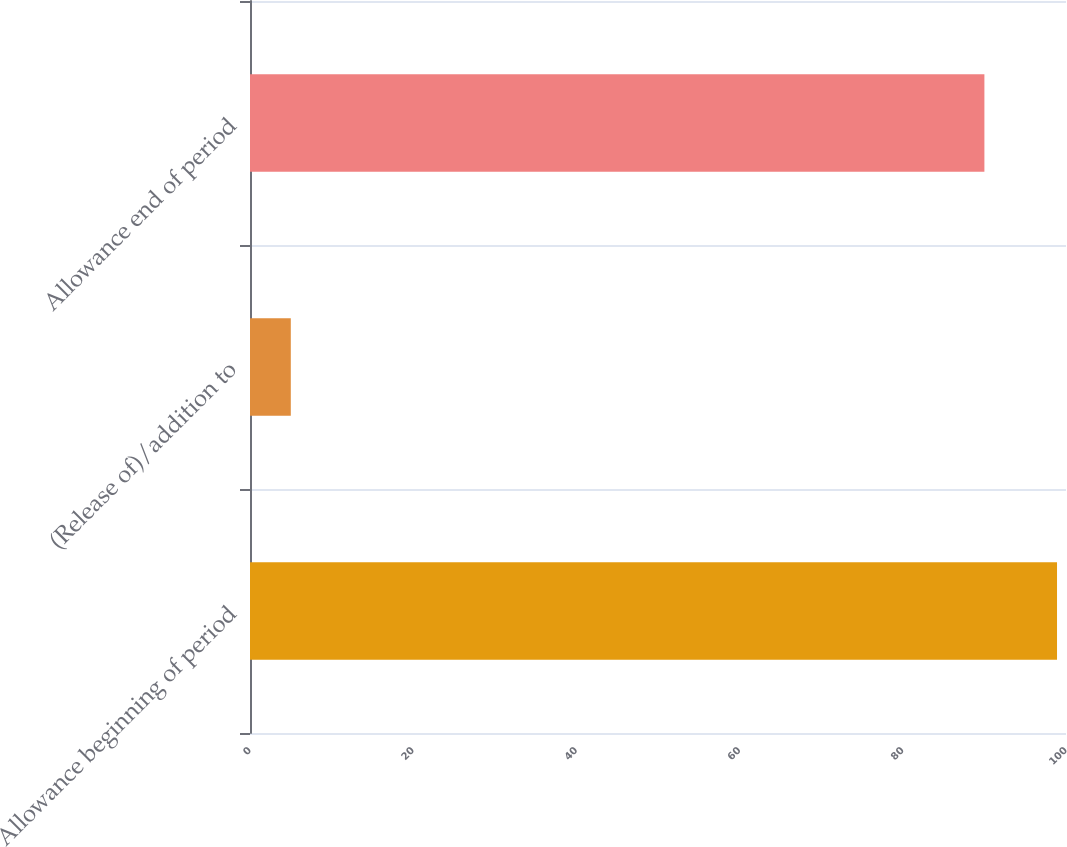Convert chart. <chart><loc_0><loc_0><loc_500><loc_500><bar_chart><fcel>Allowance beginning of period<fcel>(Release of)/addition to<fcel>Allowance end of period<nl><fcel>98.9<fcel>5<fcel>90<nl></chart> 